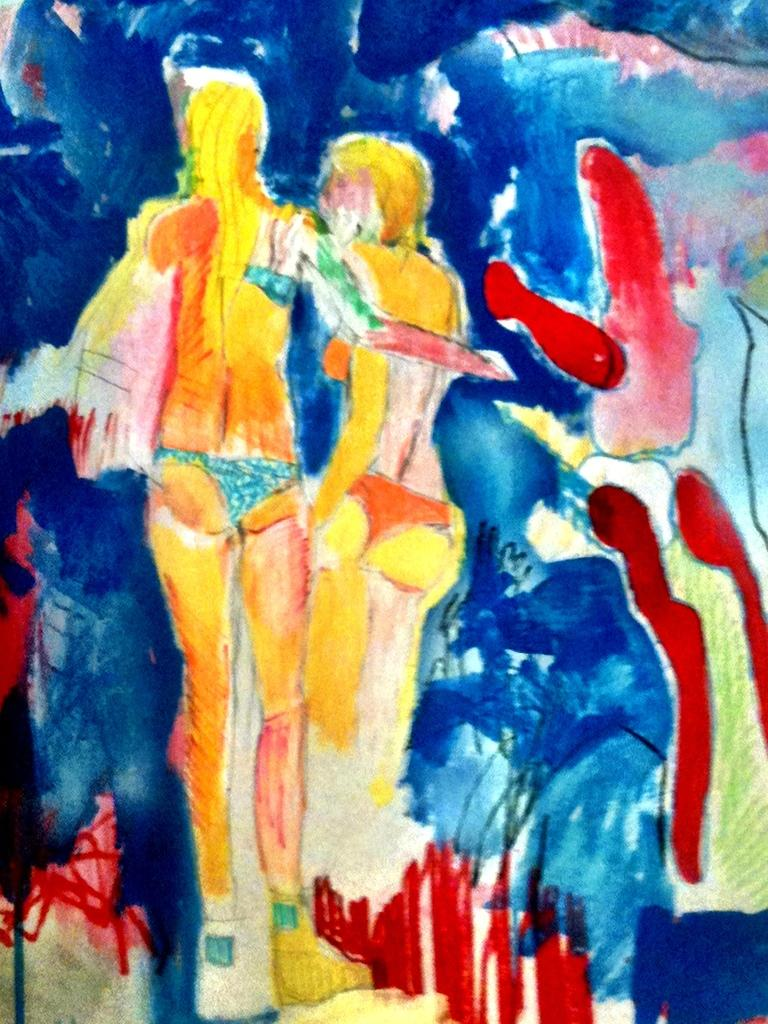What type of artwork is featured in the image? The image contains a sketch painting. What is the subject matter of the sketch painting? The sketch painting depicts two women. What are the women wearing in the sketch painting? The women are wearing bikinis. How comfortable are the women in the sketch painting? The image does not provide information about the comfort level of the women in the sketch painting. --- 